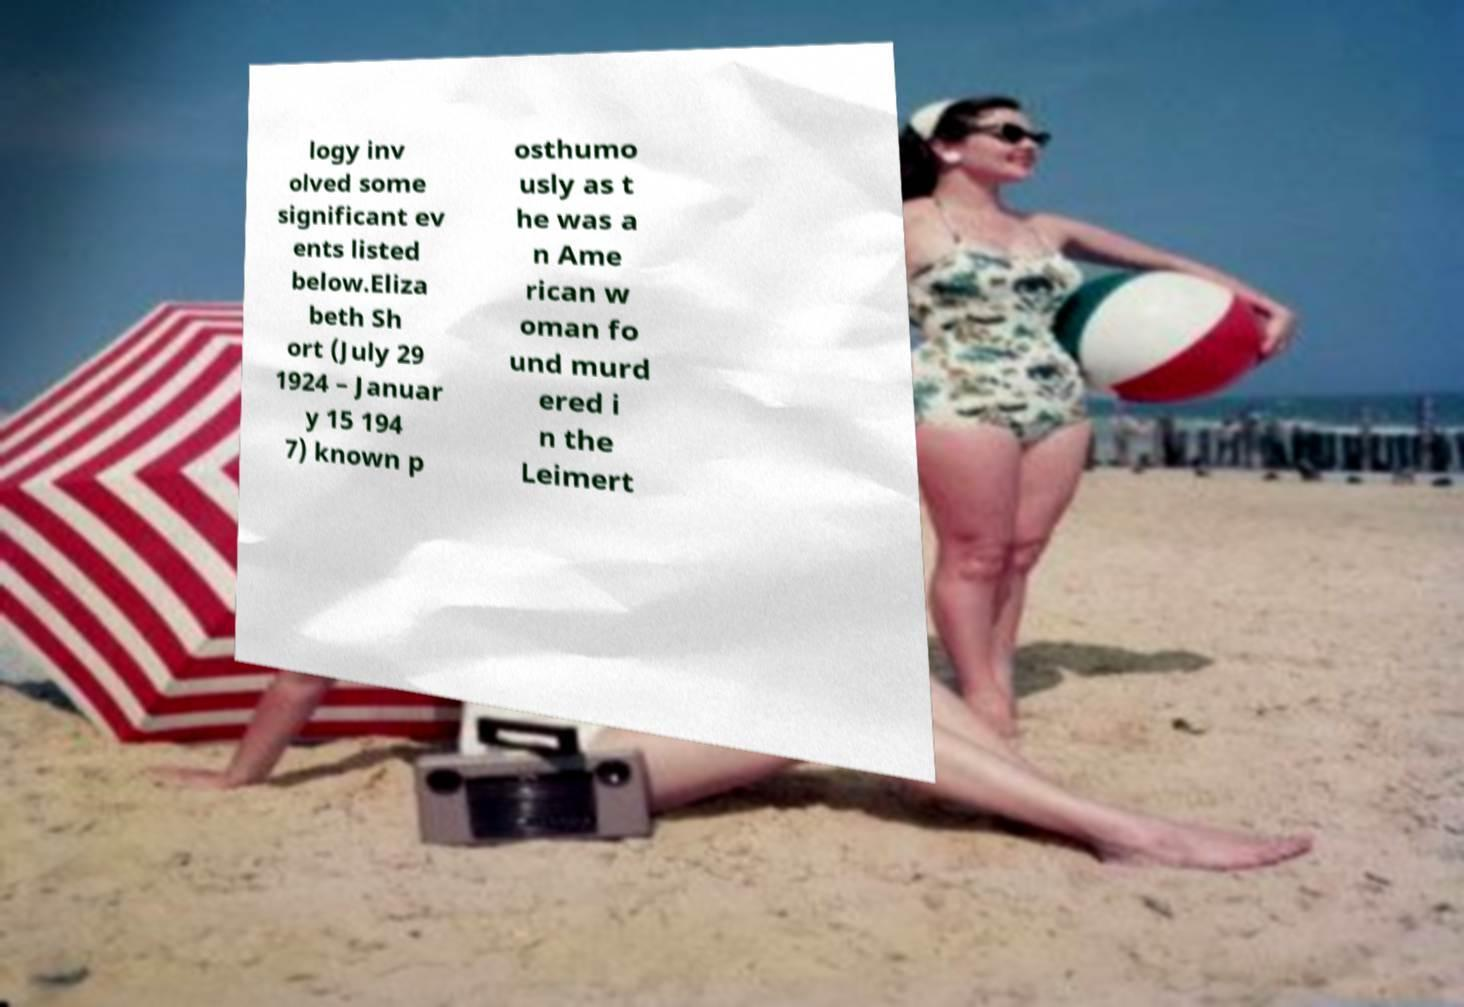For documentation purposes, I need the text within this image transcribed. Could you provide that? logy inv olved some significant ev ents listed below.Eliza beth Sh ort (July 29 1924 – Januar y 15 194 7) known p osthumo usly as t he was a n Ame rican w oman fo und murd ered i n the Leimert 